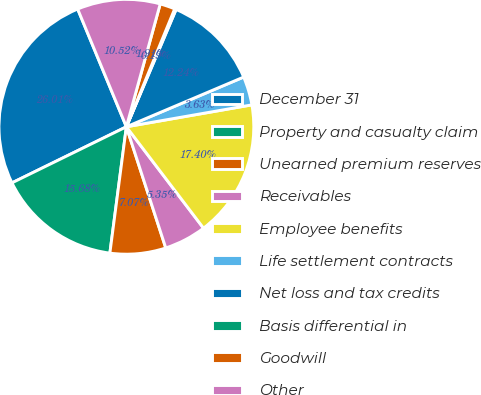Convert chart to OTSL. <chart><loc_0><loc_0><loc_500><loc_500><pie_chart><fcel>December 31<fcel>Property and casualty claim<fcel>Unearned premium reserves<fcel>Receivables<fcel>Employee benefits<fcel>Life settlement contracts<fcel>Net loss and tax credits<fcel>Basis differential in<fcel>Goodwill<fcel>Other<nl><fcel>26.01%<fcel>15.68%<fcel>7.07%<fcel>5.35%<fcel>17.4%<fcel>3.63%<fcel>12.24%<fcel>0.19%<fcel>1.91%<fcel>10.52%<nl></chart> 